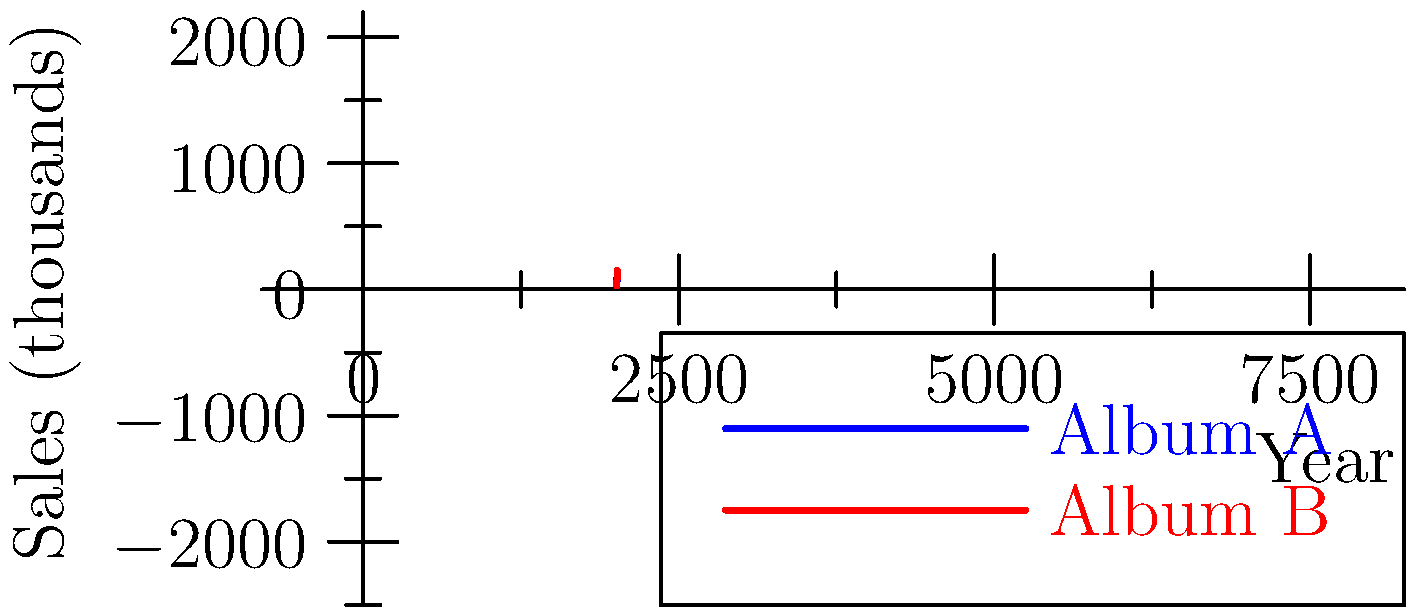The graph shows the sales trends of two Hillsong United albums over five years. If we represent each album's sales as a vector in 5D space (one dimension per year), what is the magnitude of the vector sum of both albums' sales vectors, rounded to the nearest thousand? To solve this problem, we'll follow these steps:

1) First, we need to identify the components of each vector:
   Album A: (50, 80, 120, 100, 70)
   Album B: (30, 60, 90, 150, 130)

2) To find the vector sum, we add the corresponding components:
   Sum = (50+30, 80+60, 120+90, 100+150, 70+130)
       = (80, 140, 210, 250, 200)

3) Now, we need to calculate the magnitude of this sum vector. In an n-dimensional space, the magnitude is given by the square root of the sum of squares of all components:

   $$\text{Magnitude} = \sqrt{80^2 + 140^2 + 210^2 + 250^2 + 200^2}$$

4) Let's calculate:
   $$\sqrt{6400 + 19600 + 44100 + 62500 + 40000}$$
   $$= \sqrt{172600}$$
   $$\approx 415.45$$

5) Rounding to the nearest thousand:
   415.45 rounds to 415 thousand
Answer: 415 thousand 